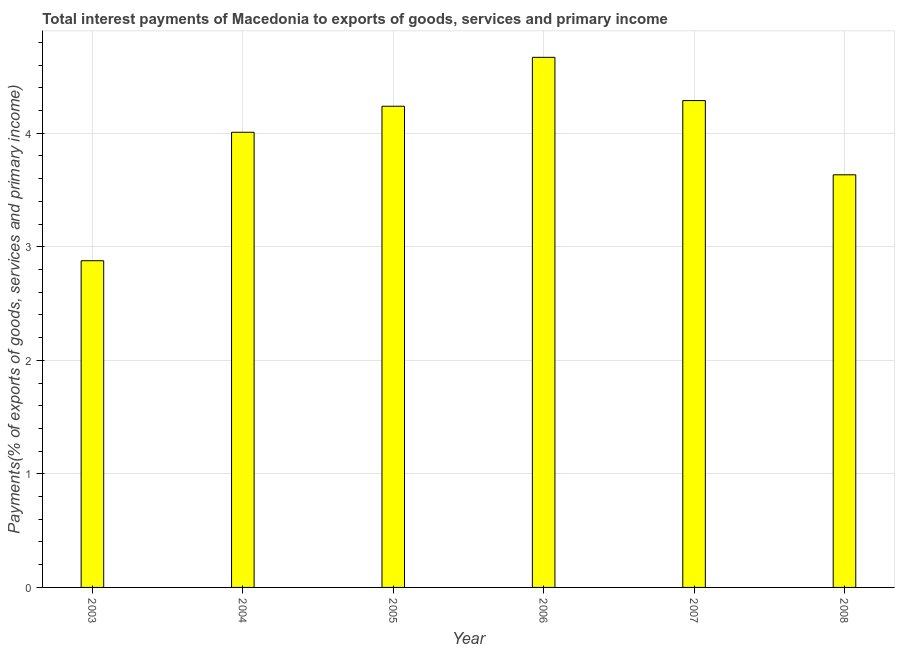Does the graph contain any zero values?
Provide a short and direct response. No. What is the title of the graph?
Offer a terse response. Total interest payments of Macedonia to exports of goods, services and primary income. What is the label or title of the X-axis?
Provide a short and direct response. Year. What is the label or title of the Y-axis?
Offer a terse response. Payments(% of exports of goods, services and primary income). What is the total interest payments on external debt in 2008?
Give a very brief answer. 3.63. Across all years, what is the maximum total interest payments on external debt?
Your answer should be compact. 4.67. Across all years, what is the minimum total interest payments on external debt?
Provide a succinct answer. 2.88. In which year was the total interest payments on external debt maximum?
Keep it short and to the point. 2006. In which year was the total interest payments on external debt minimum?
Your response must be concise. 2003. What is the sum of the total interest payments on external debt?
Make the answer very short. 23.71. What is the difference between the total interest payments on external debt in 2006 and 2007?
Your answer should be compact. 0.38. What is the average total interest payments on external debt per year?
Provide a short and direct response. 3.95. What is the median total interest payments on external debt?
Offer a terse response. 4.12. In how many years, is the total interest payments on external debt greater than 3.4 %?
Give a very brief answer. 5. What is the ratio of the total interest payments on external debt in 2006 to that in 2008?
Your answer should be compact. 1.28. Is the total interest payments on external debt in 2003 less than that in 2005?
Provide a short and direct response. Yes. What is the difference between the highest and the second highest total interest payments on external debt?
Your response must be concise. 0.38. What is the difference between the highest and the lowest total interest payments on external debt?
Keep it short and to the point. 1.79. In how many years, is the total interest payments on external debt greater than the average total interest payments on external debt taken over all years?
Provide a succinct answer. 4. Are all the bars in the graph horizontal?
Offer a terse response. No. How many years are there in the graph?
Ensure brevity in your answer.  6. What is the difference between two consecutive major ticks on the Y-axis?
Your answer should be very brief. 1. What is the Payments(% of exports of goods, services and primary income) of 2003?
Make the answer very short. 2.88. What is the Payments(% of exports of goods, services and primary income) of 2004?
Make the answer very short. 4.01. What is the Payments(% of exports of goods, services and primary income) in 2005?
Your answer should be compact. 4.24. What is the Payments(% of exports of goods, services and primary income) in 2006?
Your response must be concise. 4.67. What is the Payments(% of exports of goods, services and primary income) in 2007?
Offer a terse response. 4.29. What is the Payments(% of exports of goods, services and primary income) of 2008?
Offer a terse response. 3.63. What is the difference between the Payments(% of exports of goods, services and primary income) in 2003 and 2004?
Provide a short and direct response. -1.13. What is the difference between the Payments(% of exports of goods, services and primary income) in 2003 and 2005?
Give a very brief answer. -1.36. What is the difference between the Payments(% of exports of goods, services and primary income) in 2003 and 2006?
Give a very brief answer. -1.79. What is the difference between the Payments(% of exports of goods, services and primary income) in 2003 and 2007?
Your answer should be compact. -1.41. What is the difference between the Payments(% of exports of goods, services and primary income) in 2003 and 2008?
Your answer should be compact. -0.76. What is the difference between the Payments(% of exports of goods, services and primary income) in 2004 and 2005?
Keep it short and to the point. -0.23. What is the difference between the Payments(% of exports of goods, services and primary income) in 2004 and 2006?
Your answer should be compact. -0.66. What is the difference between the Payments(% of exports of goods, services and primary income) in 2004 and 2007?
Your response must be concise. -0.28. What is the difference between the Payments(% of exports of goods, services and primary income) in 2004 and 2008?
Offer a terse response. 0.37. What is the difference between the Payments(% of exports of goods, services and primary income) in 2005 and 2006?
Offer a very short reply. -0.43. What is the difference between the Payments(% of exports of goods, services and primary income) in 2005 and 2007?
Provide a short and direct response. -0.05. What is the difference between the Payments(% of exports of goods, services and primary income) in 2005 and 2008?
Offer a terse response. 0.6. What is the difference between the Payments(% of exports of goods, services and primary income) in 2006 and 2007?
Provide a succinct answer. 0.38. What is the difference between the Payments(% of exports of goods, services and primary income) in 2006 and 2008?
Ensure brevity in your answer.  1.03. What is the difference between the Payments(% of exports of goods, services and primary income) in 2007 and 2008?
Offer a very short reply. 0.65. What is the ratio of the Payments(% of exports of goods, services and primary income) in 2003 to that in 2004?
Offer a terse response. 0.72. What is the ratio of the Payments(% of exports of goods, services and primary income) in 2003 to that in 2005?
Your answer should be compact. 0.68. What is the ratio of the Payments(% of exports of goods, services and primary income) in 2003 to that in 2006?
Offer a terse response. 0.62. What is the ratio of the Payments(% of exports of goods, services and primary income) in 2003 to that in 2007?
Ensure brevity in your answer.  0.67. What is the ratio of the Payments(% of exports of goods, services and primary income) in 2003 to that in 2008?
Offer a terse response. 0.79. What is the ratio of the Payments(% of exports of goods, services and primary income) in 2004 to that in 2005?
Keep it short and to the point. 0.95. What is the ratio of the Payments(% of exports of goods, services and primary income) in 2004 to that in 2006?
Your response must be concise. 0.86. What is the ratio of the Payments(% of exports of goods, services and primary income) in 2004 to that in 2007?
Provide a short and direct response. 0.94. What is the ratio of the Payments(% of exports of goods, services and primary income) in 2004 to that in 2008?
Offer a very short reply. 1.1. What is the ratio of the Payments(% of exports of goods, services and primary income) in 2005 to that in 2006?
Give a very brief answer. 0.91. What is the ratio of the Payments(% of exports of goods, services and primary income) in 2005 to that in 2007?
Your response must be concise. 0.99. What is the ratio of the Payments(% of exports of goods, services and primary income) in 2005 to that in 2008?
Make the answer very short. 1.17. What is the ratio of the Payments(% of exports of goods, services and primary income) in 2006 to that in 2007?
Your answer should be compact. 1.09. What is the ratio of the Payments(% of exports of goods, services and primary income) in 2006 to that in 2008?
Your response must be concise. 1.28. What is the ratio of the Payments(% of exports of goods, services and primary income) in 2007 to that in 2008?
Give a very brief answer. 1.18. 